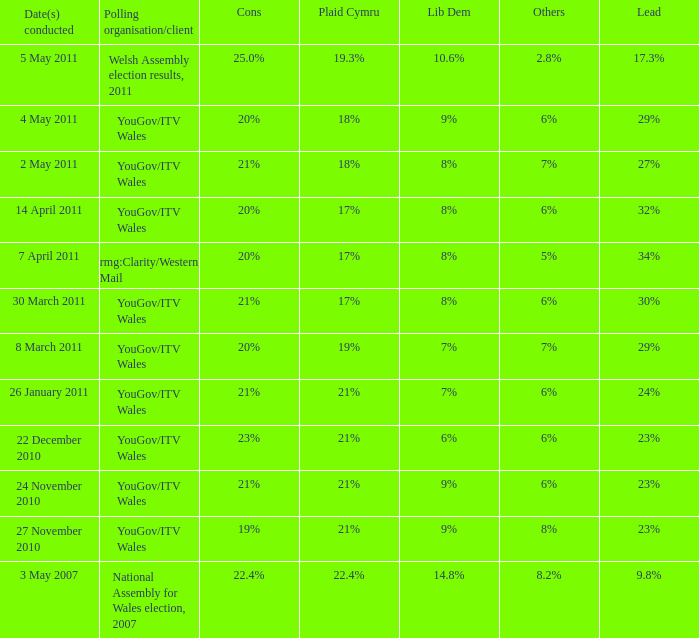Tell me the dates conducted for plaid cymru of 19% 8 March 2011. 